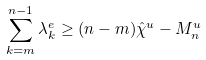<formula> <loc_0><loc_0><loc_500><loc_500>\sum _ { k = m } ^ { n - 1 } \lambda _ { k } ^ { e } \geq ( n - m ) \hat { \chi } ^ { u } - M _ { n } ^ { u }</formula> 